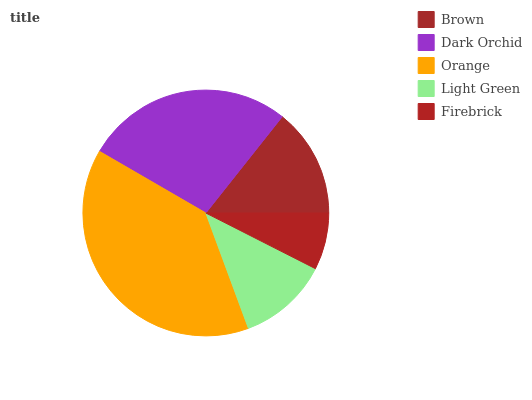Is Firebrick the minimum?
Answer yes or no. Yes. Is Orange the maximum?
Answer yes or no. Yes. Is Dark Orchid the minimum?
Answer yes or no. No. Is Dark Orchid the maximum?
Answer yes or no. No. Is Dark Orchid greater than Brown?
Answer yes or no. Yes. Is Brown less than Dark Orchid?
Answer yes or no. Yes. Is Brown greater than Dark Orchid?
Answer yes or no. No. Is Dark Orchid less than Brown?
Answer yes or no. No. Is Brown the high median?
Answer yes or no. Yes. Is Brown the low median?
Answer yes or no. Yes. Is Dark Orchid the high median?
Answer yes or no. No. Is Light Green the low median?
Answer yes or no. No. 